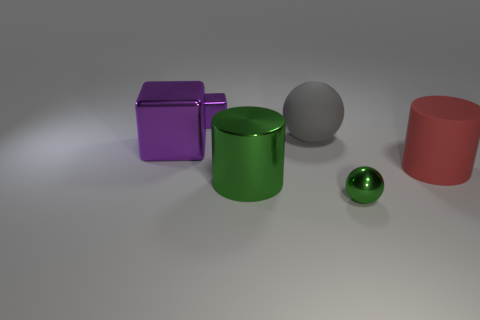There is a tiny thing that is in front of the green shiny cylinder; does it have the same shape as the gray rubber thing? yes 